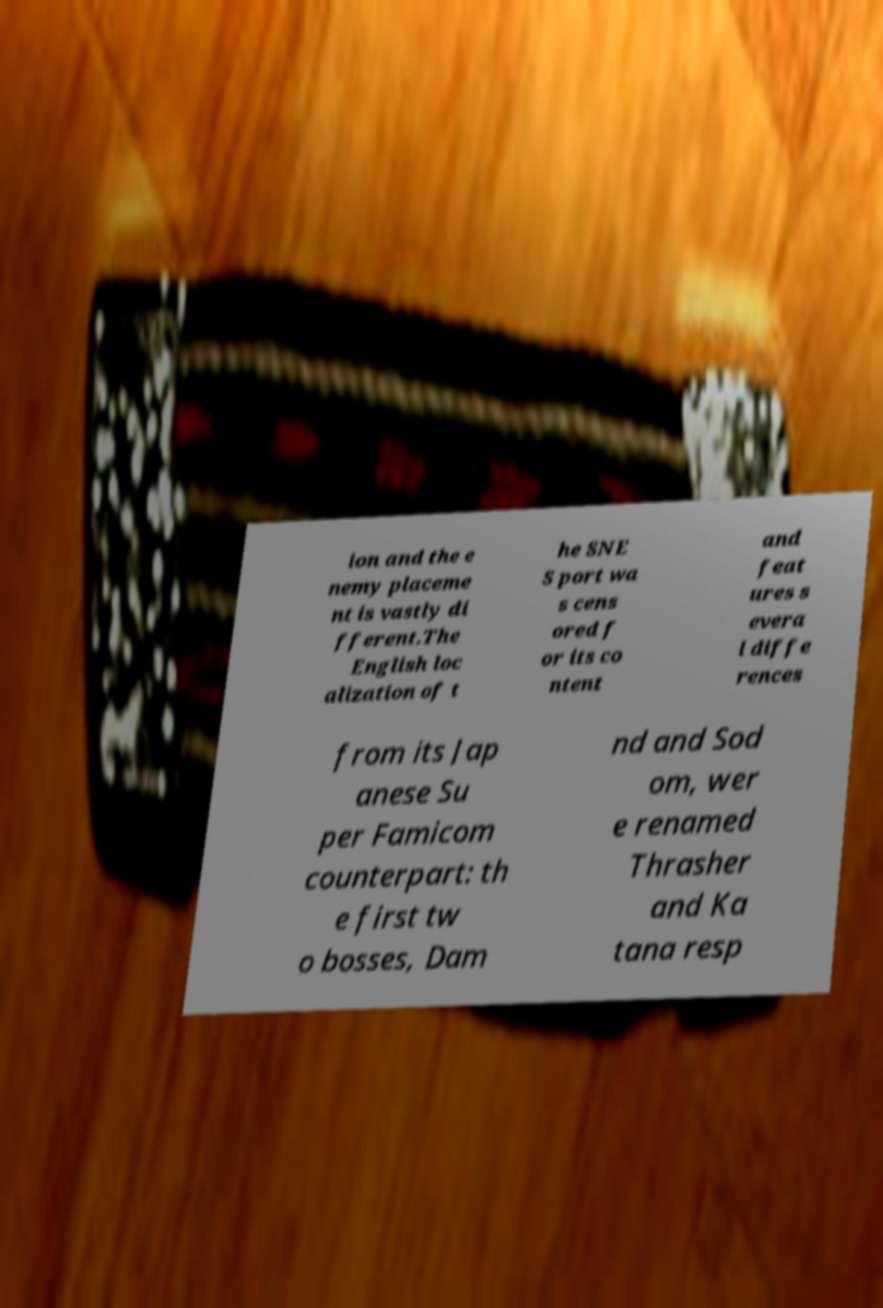I need the written content from this picture converted into text. Can you do that? ion and the e nemy placeme nt is vastly di fferent.The English loc alization of t he SNE S port wa s cens ored f or its co ntent and feat ures s evera l diffe rences from its Jap anese Su per Famicom counterpart: th e first tw o bosses, Dam nd and Sod om, wer e renamed Thrasher and Ka tana resp 